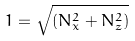Convert formula to latex. <formula><loc_0><loc_0><loc_500><loc_500>1 = \sqrt { ( N _ { x } ^ { 2 } + N _ { z } ^ { 2 } ) }</formula> 